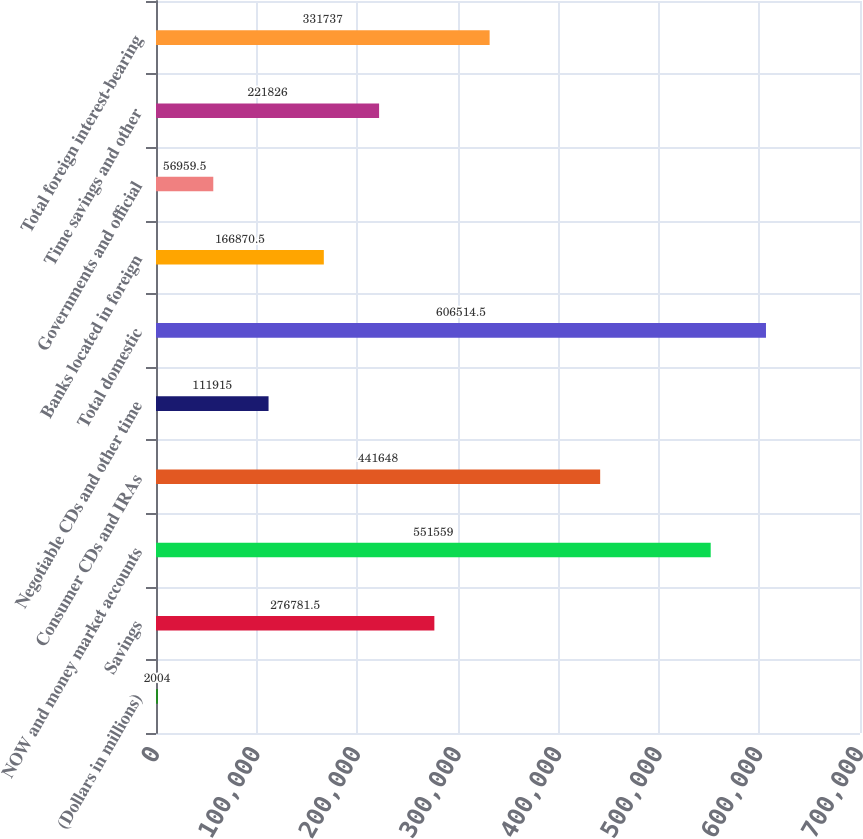<chart> <loc_0><loc_0><loc_500><loc_500><bar_chart><fcel>(Dollars in millions)<fcel>Savings<fcel>NOW and money market accounts<fcel>Consumer CDs and IRAs<fcel>Negotiable CDs and other time<fcel>Total domestic<fcel>Banks located in foreign<fcel>Governments and official<fcel>Time savings and other<fcel>Total foreign interest-bearing<nl><fcel>2004<fcel>276782<fcel>551559<fcel>441648<fcel>111915<fcel>606514<fcel>166870<fcel>56959.5<fcel>221826<fcel>331737<nl></chart> 